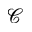<formula> <loc_0><loc_0><loc_500><loc_500>\mathcal { C }</formula> 